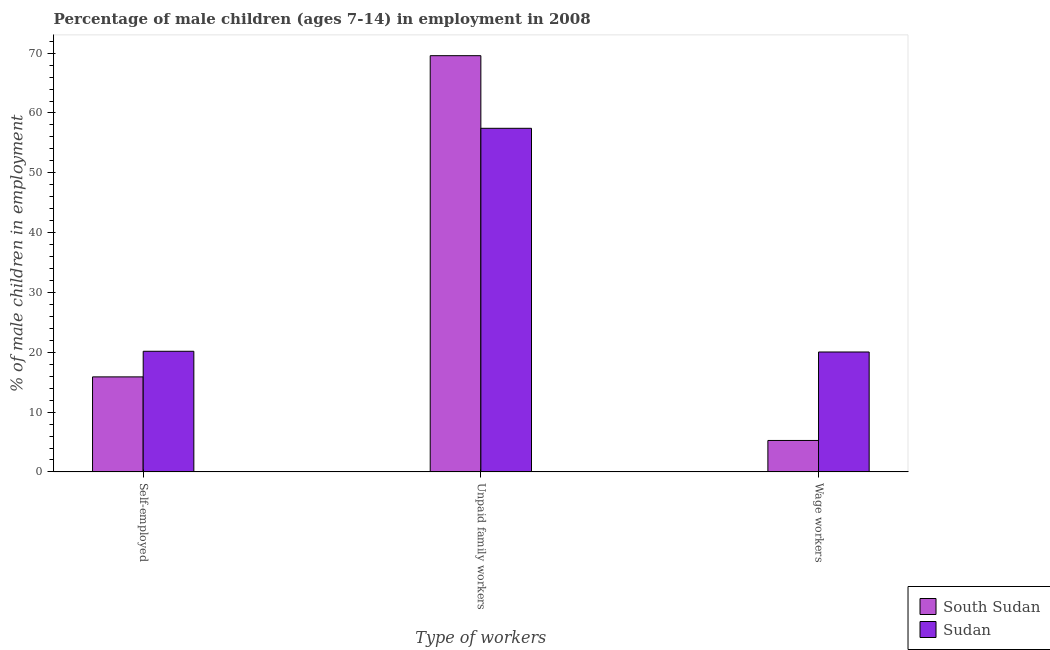How many different coloured bars are there?
Make the answer very short. 2. Are the number of bars per tick equal to the number of legend labels?
Your answer should be very brief. Yes. Are the number of bars on each tick of the X-axis equal?
Provide a short and direct response. Yes. How many bars are there on the 1st tick from the right?
Offer a terse response. 2. What is the label of the 2nd group of bars from the left?
Your answer should be compact. Unpaid family workers. What is the percentage of children employed as wage workers in South Sudan?
Ensure brevity in your answer.  5.26. Across all countries, what is the maximum percentage of self employed children?
Your response must be concise. 20.17. Across all countries, what is the minimum percentage of children employed as wage workers?
Provide a succinct answer. 5.26. In which country was the percentage of self employed children maximum?
Your response must be concise. Sudan. In which country was the percentage of self employed children minimum?
Your answer should be very brief. South Sudan. What is the total percentage of children employed as wage workers in the graph?
Offer a terse response. 25.31. What is the difference between the percentage of children employed as wage workers in South Sudan and that in Sudan?
Offer a terse response. -14.79. What is the difference between the percentage of children employed as wage workers in Sudan and the percentage of children employed as unpaid family workers in South Sudan?
Offer a terse response. -49.53. What is the average percentage of children employed as unpaid family workers per country?
Keep it short and to the point. 63.51. What is the difference between the percentage of children employed as wage workers and percentage of children employed as unpaid family workers in South Sudan?
Keep it short and to the point. -64.32. In how many countries, is the percentage of self employed children greater than 56 %?
Offer a terse response. 0. What is the ratio of the percentage of children employed as wage workers in Sudan to that in South Sudan?
Your answer should be compact. 3.81. What is the difference between the highest and the second highest percentage of children employed as wage workers?
Your answer should be very brief. 14.79. What is the difference between the highest and the lowest percentage of children employed as wage workers?
Ensure brevity in your answer.  14.79. In how many countries, is the percentage of self employed children greater than the average percentage of self employed children taken over all countries?
Your answer should be compact. 1. What does the 2nd bar from the left in Self-employed represents?
Give a very brief answer. Sudan. What does the 1st bar from the right in Wage workers represents?
Your answer should be very brief. Sudan. What is the difference between two consecutive major ticks on the Y-axis?
Ensure brevity in your answer.  10. Where does the legend appear in the graph?
Make the answer very short. Bottom right. What is the title of the graph?
Provide a succinct answer. Percentage of male children (ages 7-14) in employment in 2008. Does "Uganda" appear as one of the legend labels in the graph?
Make the answer very short. No. What is the label or title of the X-axis?
Your answer should be compact. Type of workers. What is the label or title of the Y-axis?
Ensure brevity in your answer.  % of male children in employment. What is the % of male children in employment of South Sudan in Self-employed?
Keep it short and to the point. 15.89. What is the % of male children in employment of Sudan in Self-employed?
Your answer should be compact. 20.17. What is the % of male children in employment of South Sudan in Unpaid family workers?
Give a very brief answer. 69.58. What is the % of male children in employment in Sudan in Unpaid family workers?
Offer a terse response. 57.44. What is the % of male children in employment of South Sudan in Wage workers?
Make the answer very short. 5.26. What is the % of male children in employment in Sudan in Wage workers?
Provide a succinct answer. 20.05. Across all Type of workers, what is the maximum % of male children in employment in South Sudan?
Give a very brief answer. 69.58. Across all Type of workers, what is the maximum % of male children in employment of Sudan?
Your answer should be compact. 57.44. Across all Type of workers, what is the minimum % of male children in employment in South Sudan?
Give a very brief answer. 5.26. Across all Type of workers, what is the minimum % of male children in employment of Sudan?
Provide a short and direct response. 20.05. What is the total % of male children in employment in South Sudan in the graph?
Give a very brief answer. 90.73. What is the total % of male children in employment of Sudan in the graph?
Make the answer very short. 97.66. What is the difference between the % of male children in employment of South Sudan in Self-employed and that in Unpaid family workers?
Your response must be concise. -53.69. What is the difference between the % of male children in employment of Sudan in Self-employed and that in Unpaid family workers?
Your response must be concise. -37.27. What is the difference between the % of male children in employment in South Sudan in Self-employed and that in Wage workers?
Your response must be concise. 10.63. What is the difference between the % of male children in employment in Sudan in Self-employed and that in Wage workers?
Provide a short and direct response. 0.12. What is the difference between the % of male children in employment of South Sudan in Unpaid family workers and that in Wage workers?
Your answer should be very brief. 64.32. What is the difference between the % of male children in employment of Sudan in Unpaid family workers and that in Wage workers?
Your answer should be very brief. 37.39. What is the difference between the % of male children in employment of South Sudan in Self-employed and the % of male children in employment of Sudan in Unpaid family workers?
Provide a short and direct response. -41.55. What is the difference between the % of male children in employment of South Sudan in Self-employed and the % of male children in employment of Sudan in Wage workers?
Make the answer very short. -4.16. What is the difference between the % of male children in employment in South Sudan in Unpaid family workers and the % of male children in employment in Sudan in Wage workers?
Offer a very short reply. 49.53. What is the average % of male children in employment in South Sudan per Type of workers?
Keep it short and to the point. 30.24. What is the average % of male children in employment of Sudan per Type of workers?
Give a very brief answer. 32.55. What is the difference between the % of male children in employment in South Sudan and % of male children in employment in Sudan in Self-employed?
Provide a succinct answer. -4.28. What is the difference between the % of male children in employment in South Sudan and % of male children in employment in Sudan in Unpaid family workers?
Your response must be concise. 12.14. What is the difference between the % of male children in employment of South Sudan and % of male children in employment of Sudan in Wage workers?
Give a very brief answer. -14.79. What is the ratio of the % of male children in employment in South Sudan in Self-employed to that in Unpaid family workers?
Offer a very short reply. 0.23. What is the ratio of the % of male children in employment in Sudan in Self-employed to that in Unpaid family workers?
Give a very brief answer. 0.35. What is the ratio of the % of male children in employment of South Sudan in Self-employed to that in Wage workers?
Make the answer very short. 3.02. What is the ratio of the % of male children in employment in South Sudan in Unpaid family workers to that in Wage workers?
Your response must be concise. 13.23. What is the ratio of the % of male children in employment of Sudan in Unpaid family workers to that in Wage workers?
Provide a short and direct response. 2.86. What is the difference between the highest and the second highest % of male children in employment of South Sudan?
Give a very brief answer. 53.69. What is the difference between the highest and the second highest % of male children in employment of Sudan?
Keep it short and to the point. 37.27. What is the difference between the highest and the lowest % of male children in employment in South Sudan?
Your answer should be compact. 64.32. What is the difference between the highest and the lowest % of male children in employment in Sudan?
Offer a terse response. 37.39. 